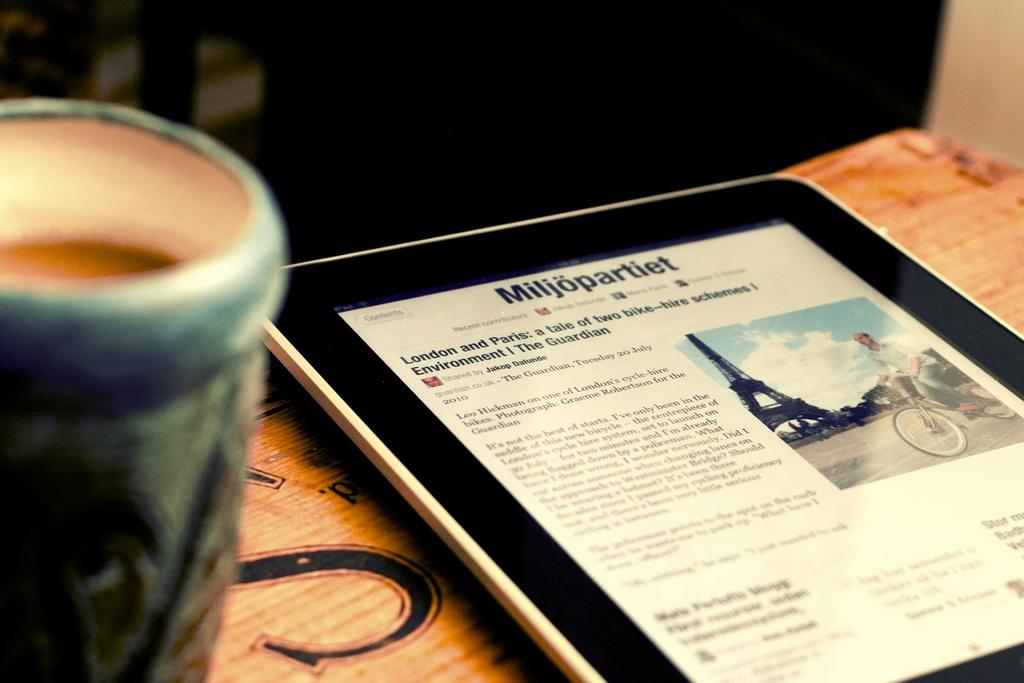In what language is miljpartiet website?
Your answer should be compact. Unanswerable. Which two counties are referenced in the title of the article?
Keep it short and to the point. London and paris. 